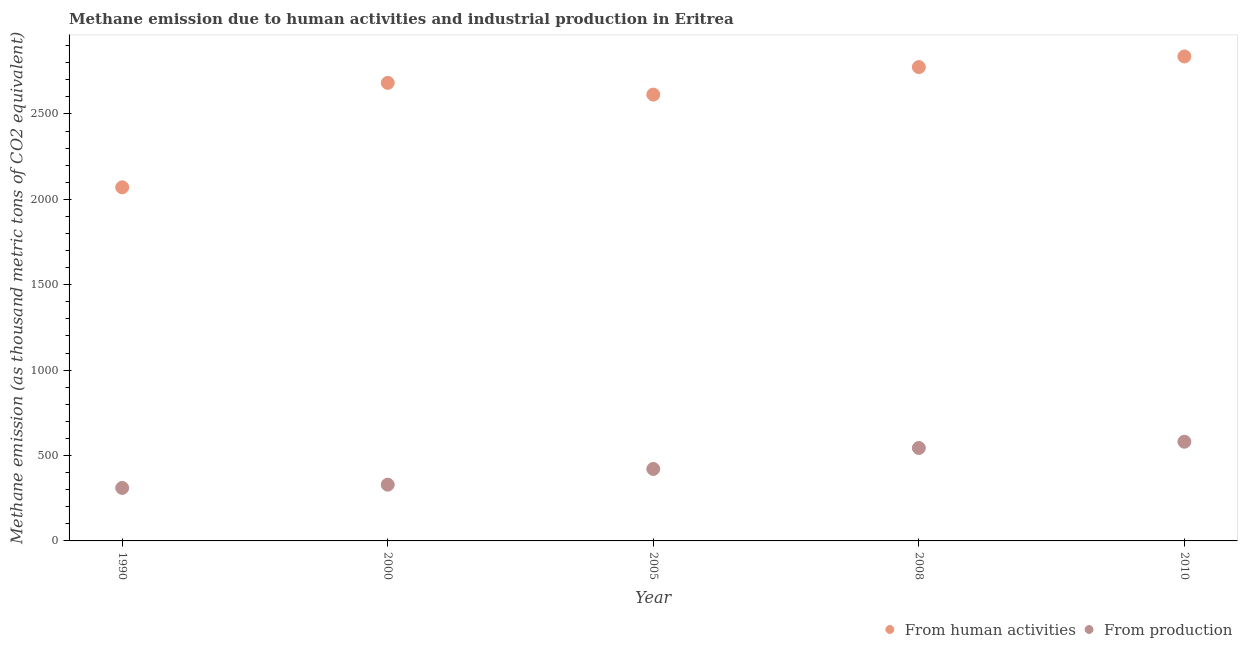What is the amount of emissions generated from industries in 2005?
Your answer should be compact. 421.4. Across all years, what is the maximum amount of emissions from human activities?
Offer a very short reply. 2837. Across all years, what is the minimum amount of emissions from human activities?
Offer a very short reply. 2070.6. In which year was the amount of emissions generated from industries maximum?
Your answer should be very brief. 2010. In which year was the amount of emissions from human activities minimum?
Ensure brevity in your answer.  1990. What is the total amount of emissions generated from industries in the graph?
Provide a short and direct response. 2186.3. What is the difference between the amount of emissions from human activities in 2010 and the amount of emissions generated from industries in 1990?
Offer a terse response. 2526.6. What is the average amount of emissions from human activities per year?
Offer a very short reply. 2595.64. In the year 2000, what is the difference between the amount of emissions from human activities and amount of emissions generated from industries?
Ensure brevity in your answer.  2352.9. What is the ratio of the amount of emissions generated from industries in 2005 to that in 2010?
Provide a short and direct response. 0.73. Is the difference between the amount of emissions from human activities in 2000 and 2008 greater than the difference between the amount of emissions generated from industries in 2000 and 2008?
Ensure brevity in your answer.  Yes. What is the difference between the highest and the second highest amount of emissions from human activities?
Your answer should be compact. 62.3. What is the difference between the highest and the lowest amount of emissions generated from industries?
Ensure brevity in your answer.  270.5. Is the amount of emissions from human activities strictly greater than the amount of emissions generated from industries over the years?
Offer a very short reply. Yes. Is the amount of emissions from human activities strictly less than the amount of emissions generated from industries over the years?
Make the answer very short. No. How many dotlines are there?
Give a very brief answer. 2. Does the graph contain grids?
Your answer should be compact. No. Where does the legend appear in the graph?
Your answer should be very brief. Bottom right. What is the title of the graph?
Provide a succinct answer. Methane emission due to human activities and industrial production in Eritrea. What is the label or title of the X-axis?
Offer a very short reply. Year. What is the label or title of the Y-axis?
Ensure brevity in your answer.  Methane emission (as thousand metric tons of CO2 equivalent). What is the Methane emission (as thousand metric tons of CO2 equivalent) of From human activities in 1990?
Give a very brief answer. 2070.6. What is the Methane emission (as thousand metric tons of CO2 equivalent) in From production in 1990?
Your answer should be very brief. 310.4. What is the Methane emission (as thousand metric tons of CO2 equivalent) of From human activities in 2000?
Your response must be concise. 2682.3. What is the Methane emission (as thousand metric tons of CO2 equivalent) of From production in 2000?
Ensure brevity in your answer.  329.4. What is the Methane emission (as thousand metric tons of CO2 equivalent) of From human activities in 2005?
Offer a terse response. 2613.6. What is the Methane emission (as thousand metric tons of CO2 equivalent) in From production in 2005?
Offer a very short reply. 421.4. What is the Methane emission (as thousand metric tons of CO2 equivalent) in From human activities in 2008?
Provide a short and direct response. 2774.7. What is the Methane emission (as thousand metric tons of CO2 equivalent) of From production in 2008?
Your answer should be very brief. 544.2. What is the Methane emission (as thousand metric tons of CO2 equivalent) of From human activities in 2010?
Offer a terse response. 2837. What is the Methane emission (as thousand metric tons of CO2 equivalent) in From production in 2010?
Offer a very short reply. 580.9. Across all years, what is the maximum Methane emission (as thousand metric tons of CO2 equivalent) in From human activities?
Offer a terse response. 2837. Across all years, what is the maximum Methane emission (as thousand metric tons of CO2 equivalent) in From production?
Offer a terse response. 580.9. Across all years, what is the minimum Methane emission (as thousand metric tons of CO2 equivalent) in From human activities?
Make the answer very short. 2070.6. Across all years, what is the minimum Methane emission (as thousand metric tons of CO2 equivalent) of From production?
Keep it short and to the point. 310.4. What is the total Methane emission (as thousand metric tons of CO2 equivalent) in From human activities in the graph?
Keep it short and to the point. 1.30e+04. What is the total Methane emission (as thousand metric tons of CO2 equivalent) of From production in the graph?
Ensure brevity in your answer.  2186.3. What is the difference between the Methane emission (as thousand metric tons of CO2 equivalent) in From human activities in 1990 and that in 2000?
Make the answer very short. -611.7. What is the difference between the Methane emission (as thousand metric tons of CO2 equivalent) in From production in 1990 and that in 2000?
Provide a succinct answer. -19. What is the difference between the Methane emission (as thousand metric tons of CO2 equivalent) of From human activities in 1990 and that in 2005?
Provide a short and direct response. -543. What is the difference between the Methane emission (as thousand metric tons of CO2 equivalent) in From production in 1990 and that in 2005?
Offer a terse response. -111. What is the difference between the Methane emission (as thousand metric tons of CO2 equivalent) of From human activities in 1990 and that in 2008?
Your response must be concise. -704.1. What is the difference between the Methane emission (as thousand metric tons of CO2 equivalent) in From production in 1990 and that in 2008?
Keep it short and to the point. -233.8. What is the difference between the Methane emission (as thousand metric tons of CO2 equivalent) of From human activities in 1990 and that in 2010?
Give a very brief answer. -766.4. What is the difference between the Methane emission (as thousand metric tons of CO2 equivalent) of From production in 1990 and that in 2010?
Provide a succinct answer. -270.5. What is the difference between the Methane emission (as thousand metric tons of CO2 equivalent) of From human activities in 2000 and that in 2005?
Keep it short and to the point. 68.7. What is the difference between the Methane emission (as thousand metric tons of CO2 equivalent) in From production in 2000 and that in 2005?
Keep it short and to the point. -92. What is the difference between the Methane emission (as thousand metric tons of CO2 equivalent) of From human activities in 2000 and that in 2008?
Offer a terse response. -92.4. What is the difference between the Methane emission (as thousand metric tons of CO2 equivalent) in From production in 2000 and that in 2008?
Keep it short and to the point. -214.8. What is the difference between the Methane emission (as thousand metric tons of CO2 equivalent) of From human activities in 2000 and that in 2010?
Your answer should be very brief. -154.7. What is the difference between the Methane emission (as thousand metric tons of CO2 equivalent) in From production in 2000 and that in 2010?
Offer a very short reply. -251.5. What is the difference between the Methane emission (as thousand metric tons of CO2 equivalent) in From human activities in 2005 and that in 2008?
Give a very brief answer. -161.1. What is the difference between the Methane emission (as thousand metric tons of CO2 equivalent) of From production in 2005 and that in 2008?
Ensure brevity in your answer.  -122.8. What is the difference between the Methane emission (as thousand metric tons of CO2 equivalent) of From human activities in 2005 and that in 2010?
Provide a succinct answer. -223.4. What is the difference between the Methane emission (as thousand metric tons of CO2 equivalent) in From production in 2005 and that in 2010?
Make the answer very short. -159.5. What is the difference between the Methane emission (as thousand metric tons of CO2 equivalent) in From human activities in 2008 and that in 2010?
Offer a very short reply. -62.3. What is the difference between the Methane emission (as thousand metric tons of CO2 equivalent) of From production in 2008 and that in 2010?
Offer a terse response. -36.7. What is the difference between the Methane emission (as thousand metric tons of CO2 equivalent) in From human activities in 1990 and the Methane emission (as thousand metric tons of CO2 equivalent) in From production in 2000?
Offer a very short reply. 1741.2. What is the difference between the Methane emission (as thousand metric tons of CO2 equivalent) of From human activities in 1990 and the Methane emission (as thousand metric tons of CO2 equivalent) of From production in 2005?
Make the answer very short. 1649.2. What is the difference between the Methane emission (as thousand metric tons of CO2 equivalent) of From human activities in 1990 and the Methane emission (as thousand metric tons of CO2 equivalent) of From production in 2008?
Make the answer very short. 1526.4. What is the difference between the Methane emission (as thousand metric tons of CO2 equivalent) of From human activities in 1990 and the Methane emission (as thousand metric tons of CO2 equivalent) of From production in 2010?
Give a very brief answer. 1489.7. What is the difference between the Methane emission (as thousand metric tons of CO2 equivalent) of From human activities in 2000 and the Methane emission (as thousand metric tons of CO2 equivalent) of From production in 2005?
Give a very brief answer. 2260.9. What is the difference between the Methane emission (as thousand metric tons of CO2 equivalent) of From human activities in 2000 and the Methane emission (as thousand metric tons of CO2 equivalent) of From production in 2008?
Ensure brevity in your answer.  2138.1. What is the difference between the Methane emission (as thousand metric tons of CO2 equivalent) of From human activities in 2000 and the Methane emission (as thousand metric tons of CO2 equivalent) of From production in 2010?
Make the answer very short. 2101.4. What is the difference between the Methane emission (as thousand metric tons of CO2 equivalent) in From human activities in 2005 and the Methane emission (as thousand metric tons of CO2 equivalent) in From production in 2008?
Give a very brief answer. 2069.4. What is the difference between the Methane emission (as thousand metric tons of CO2 equivalent) of From human activities in 2005 and the Methane emission (as thousand metric tons of CO2 equivalent) of From production in 2010?
Provide a short and direct response. 2032.7. What is the difference between the Methane emission (as thousand metric tons of CO2 equivalent) of From human activities in 2008 and the Methane emission (as thousand metric tons of CO2 equivalent) of From production in 2010?
Provide a succinct answer. 2193.8. What is the average Methane emission (as thousand metric tons of CO2 equivalent) of From human activities per year?
Your answer should be very brief. 2595.64. What is the average Methane emission (as thousand metric tons of CO2 equivalent) in From production per year?
Provide a succinct answer. 437.26. In the year 1990, what is the difference between the Methane emission (as thousand metric tons of CO2 equivalent) of From human activities and Methane emission (as thousand metric tons of CO2 equivalent) of From production?
Provide a succinct answer. 1760.2. In the year 2000, what is the difference between the Methane emission (as thousand metric tons of CO2 equivalent) of From human activities and Methane emission (as thousand metric tons of CO2 equivalent) of From production?
Offer a very short reply. 2352.9. In the year 2005, what is the difference between the Methane emission (as thousand metric tons of CO2 equivalent) in From human activities and Methane emission (as thousand metric tons of CO2 equivalent) in From production?
Make the answer very short. 2192.2. In the year 2008, what is the difference between the Methane emission (as thousand metric tons of CO2 equivalent) in From human activities and Methane emission (as thousand metric tons of CO2 equivalent) in From production?
Make the answer very short. 2230.5. In the year 2010, what is the difference between the Methane emission (as thousand metric tons of CO2 equivalent) of From human activities and Methane emission (as thousand metric tons of CO2 equivalent) of From production?
Offer a terse response. 2256.1. What is the ratio of the Methane emission (as thousand metric tons of CO2 equivalent) in From human activities in 1990 to that in 2000?
Offer a terse response. 0.77. What is the ratio of the Methane emission (as thousand metric tons of CO2 equivalent) in From production in 1990 to that in 2000?
Make the answer very short. 0.94. What is the ratio of the Methane emission (as thousand metric tons of CO2 equivalent) of From human activities in 1990 to that in 2005?
Offer a terse response. 0.79. What is the ratio of the Methane emission (as thousand metric tons of CO2 equivalent) of From production in 1990 to that in 2005?
Offer a very short reply. 0.74. What is the ratio of the Methane emission (as thousand metric tons of CO2 equivalent) of From human activities in 1990 to that in 2008?
Offer a very short reply. 0.75. What is the ratio of the Methane emission (as thousand metric tons of CO2 equivalent) in From production in 1990 to that in 2008?
Ensure brevity in your answer.  0.57. What is the ratio of the Methane emission (as thousand metric tons of CO2 equivalent) of From human activities in 1990 to that in 2010?
Keep it short and to the point. 0.73. What is the ratio of the Methane emission (as thousand metric tons of CO2 equivalent) of From production in 1990 to that in 2010?
Your response must be concise. 0.53. What is the ratio of the Methane emission (as thousand metric tons of CO2 equivalent) of From human activities in 2000 to that in 2005?
Make the answer very short. 1.03. What is the ratio of the Methane emission (as thousand metric tons of CO2 equivalent) in From production in 2000 to that in 2005?
Your answer should be compact. 0.78. What is the ratio of the Methane emission (as thousand metric tons of CO2 equivalent) of From human activities in 2000 to that in 2008?
Provide a succinct answer. 0.97. What is the ratio of the Methane emission (as thousand metric tons of CO2 equivalent) in From production in 2000 to that in 2008?
Offer a terse response. 0.61. What is the ratio of the Methane emission (as thousand metric tons of CO2 equivalent) of From human activities in 2000 to that in 2010?
Your answer should be very brief. 0.95. What is the ratio of the Methane emission (as thousand metric tons of CO2 equivalent) of From production in 2000 to that in 2010?
Ensure brevity in your answer.  0.57. What is the ratio of the Methane emission (as thousand metric tons of CO2 equivalent) in From human activities in 2005 to that in 2008?
Provide a succinct answer. 0.94. What is the ratio of the Methane emission (as thousand metric tons of CO2 equivalent) in From production in 2005 to that in 2008?
Your answer should be very brief. 0.77. What is the ratio of the Methane emission (as thousand metric tons of CO2 equivalent) of From human activities in 2005 to that in 2010?
Your answer should be very brief. 0.92. What is the ratio of the Methane emission (as thousand metric tons of CO2 equivalent) in From production in 2005 to that in 2010?
Provide a succinct answer. 0.73. What is the ratio of the Methane emission (as thousand metric tons of CO2 equivalent) in From production in 2008 to that in 2010?
Provide a short and direct response. 0.94. What is the difference between the highest and the second highest Methane emission (as thousand metric tons of CO2 equivalent) of From human activities?
Provide a short and direct response. 62.3. What is the difference between the highest and the second highest Methane emission (as thousand metric tons of CO2 equivalent) in From production?
Give a very brief answer. 36.7. What is the difference between the highest and the lowest Methane emission (as thousand metric tons of CO2 equivalent) of From human activities?
Ensure brevity in your answer.  766.4. What is the difference between the highest and the lowest Methane emission (as thousand metric tons of CO2 equivalent) in From production?
Your answer should be very brief. 270.5. 